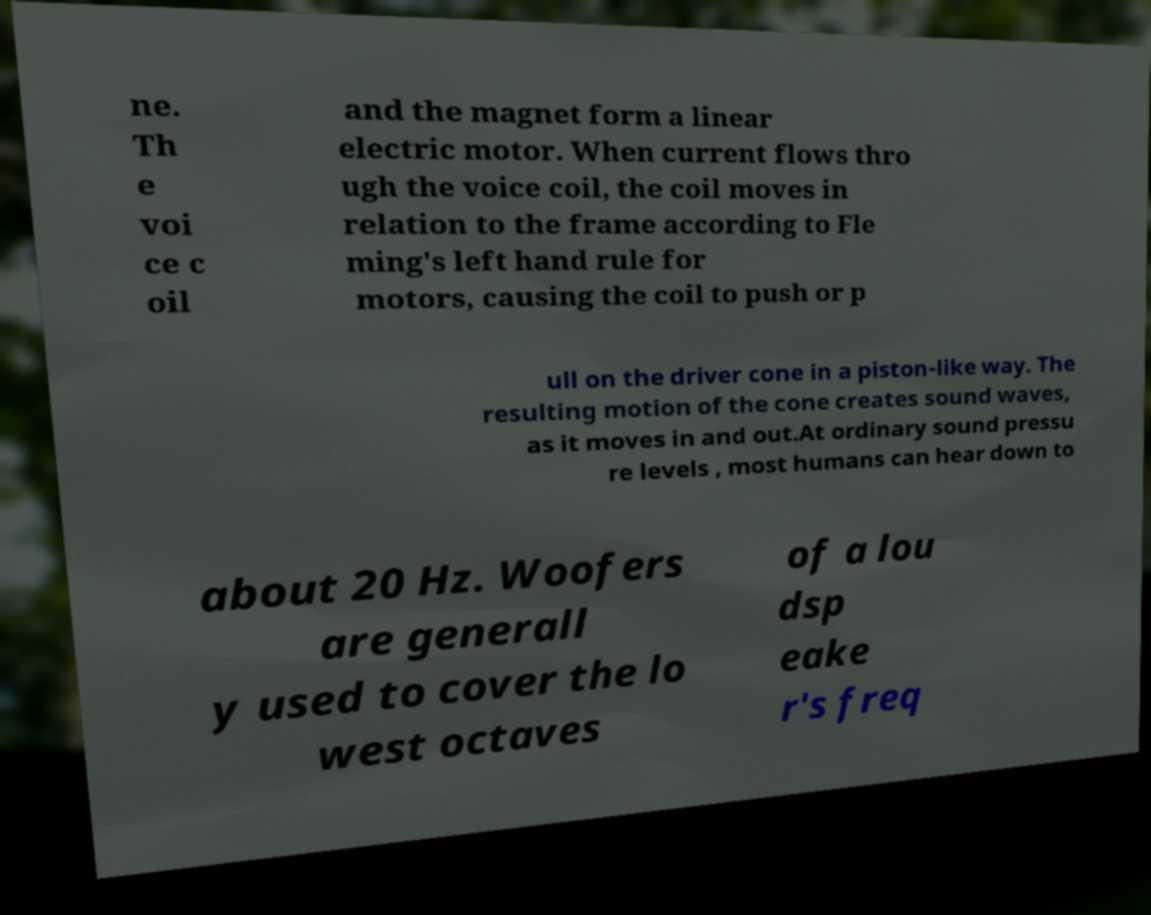I need the written content from this picture converted into text. Can you do that? ne. Th e voi ce c oil and the magnet form a linear electric motor. When current flows thro ugh the voice coil, the coil moves in relation to the frame according to Fle ming's left hand rule for motors, causing the coil to push or p ull on the driver cone in a piston-like way. The resulting motion of the cone creates sound waves, as it moves in and out.At ordinary sound pressu re levels , most humans can hear down to about 20 Hz. Woofers are generall y used to cover the lo west octaves of a lou dsp eake r's freq 